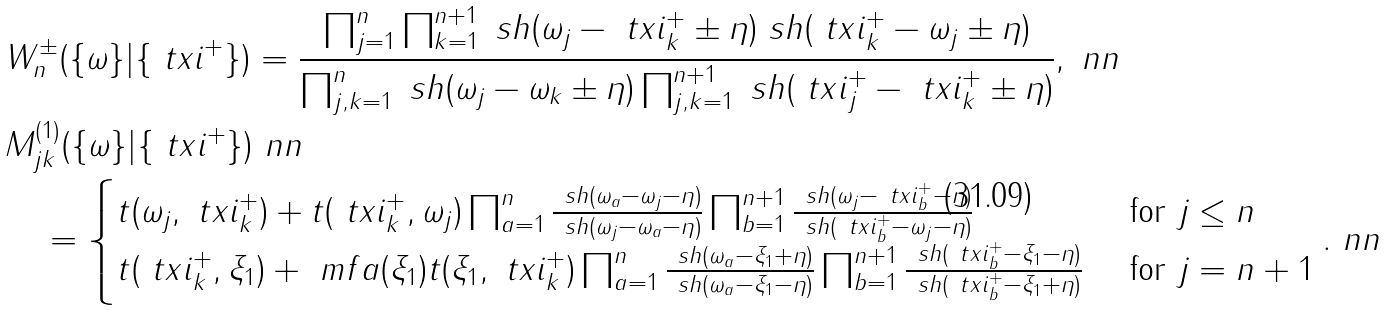Convert formula to latex. <formula><loc_0><loc_0><loc_500><loc_500>& W ^ { \pm } _ { n } ( \{ \omega \} | \{ \ t x i ^ { + } \} ) = \frac { \prod _ { j = 1 } ^ { n } \prod _ { k = 1 } ^ { n + 1 } \ s h ( \omega _ { j } - \ t x i ^ { + } _ { k } \pm \eta ) \ s h ( \ t x i ^ { + } _ { k } - \omega _ { j } \pm \eta ) } { \prod _ { j , k = 1 } ^ { n } \ s h ( \omega _ { j } - \omega _ { k } \pm \eta ) \prod _ { j , k = 1 } ^ { n + 1 } \ s h ( \ t x i ^ { + } _ { j } - \ t x i ^ { + } _ { k } \pm \eta ) } , \ n n \\ & M _ { j k } ^ { ( 1 ) } ( \{ \omega \} | \{ \ t x i ^ { + } \} ) \ n n \\ & \quad = \begin{cases} t ( \omega _ { j } , \ t x i _ { k } ^ { + } ) + t ( \ t x i _ { k } ^ { + } , \omega _ { j } ) \prod _ { a = 1 } ^ { n } \frac { \ s h ( \omega _ { a } - \omega _ { j } - \eta ) } { \ s h ( \omega _ { j } - \omega _ { a } - \eta ) } \prod _ { b = 1 } ^ { n + 1 } \frac { \ s h ( \omega _ { j } - \ t x i _ { b } ^ { + } - \eta ) } { \ s h ( \ t x i _ { b } ^ { + } - \omega _ { j } - \eta ) } & \text { for $j\leq n$} \\ t ( \ t x i _ { k } ^ { + } , \xi _ { 1 } ) + \ m f a ( \xi _ { 1 } ) t ( \xi _ { 1 } , \ t x i _ { k } ^ { + } ) \prod _ { a = 1 } ^ { n } \frac { \ s h ( \omega _ { a } - \xi _ { 1 } + \eta ) } { \ s h ( \omega _ { a } - \xi _ { 1 } - \eta ) } \prod _ { b = 1 } ^ { n + 1 } \frac { \ s h ( \ t x i _ { b } ^ { + } - \xi _ { 1 } - \eta ) } { \ s h ( \ t x i _ { b } ^ { + } - \xi _ { 1 } + \eta ) } & \text { for $j= n+1$} \end{cases} . \ n n</formula> 